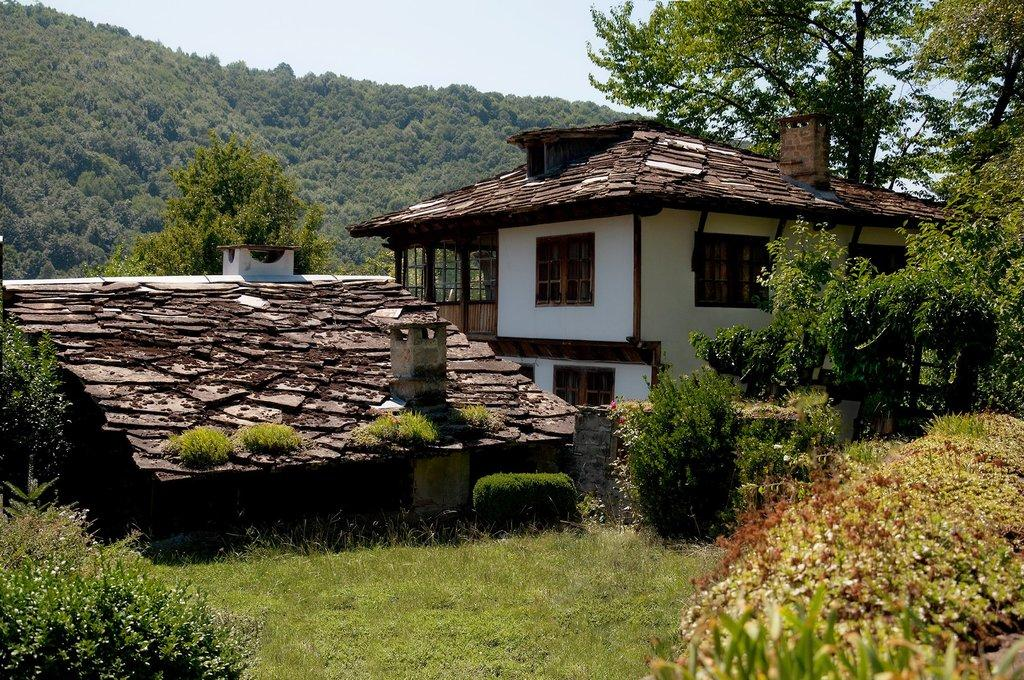What type of vegetation can be seen in the image? There is grass and plants in the image. What type of structures are present in the image? There are houses in the image. What type of natural elements can be seen in the image? There are trees in the image. What part of the natural environment is visible in the image? The sky is visible in the image. What type of farmer is shown working in the image? There is no farmer present in the image. How does the lift function in the image? There is no lift present in the image. 